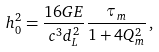Convert formula to latex. <formula><loc_0><loc_0><loc_500><loc_500>h _ { 0 } ^ { 2 } = \frac { 1 6 G E } { c ^ { 3 } d _ { L } ^ { 2 } } \frac { \tau _ { m } } { 1 + 4 Q _ { m } ^ { 2 } } \, ,</formula> 